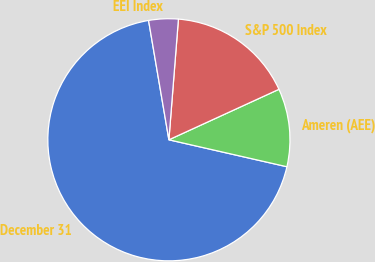Convert chart to OTSL. <chart><loc_0><loc_0><loc_500><loc_500><pie_chart><fcel>December 31<fcel>Ameren (AEE)<fcel>S&P 500 Index<fcel>EEI Index<nl><fcel>68.74%<fcel>10.42%<fcel>16.9%<fcel>3.94%<nl></chart> 